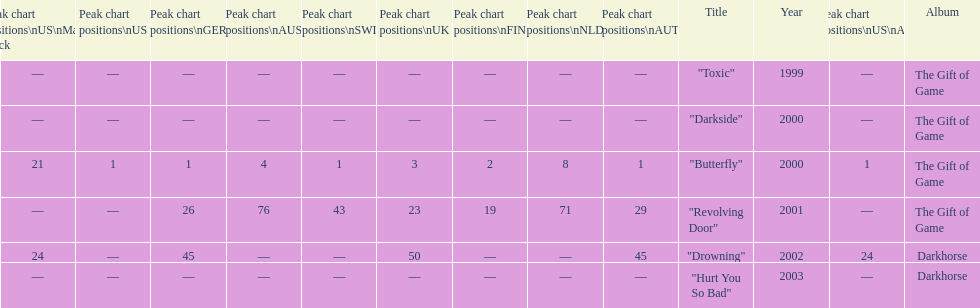How many times did the single "butterfly" rank as 1 in the chart? 5. 